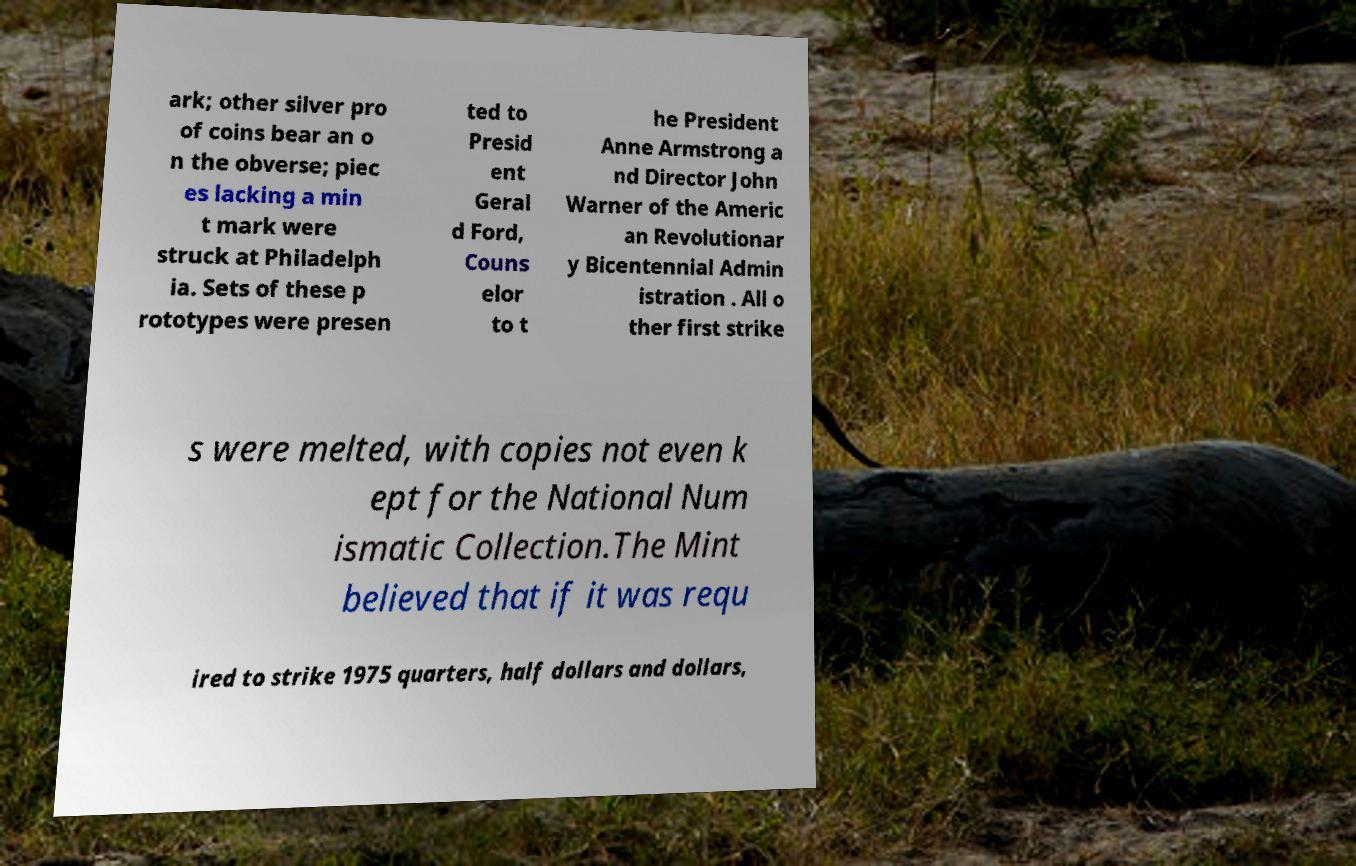Can you read and provide the text displayed in the image?This photo seems to have some interesting text. Can you extract and type it out for me? ark; other silver pro of coins bear an o n the obverse; piec es lacking a min t mark were struck at Philadelph ia. Sets of these p rototypes were presen ted to Presid ent Geral d Ford, Couns elor to t he President Anne Armstrong a nd Director John Warner of the Americ an Revolutionar y Bicentennial Admin istration . All o ther first strike s were melted, with copies not even k ept for the National Num ismatic Collection.The Mint believed that if it was requ ired to strike 1975 quarters, half dollars and dollars, 